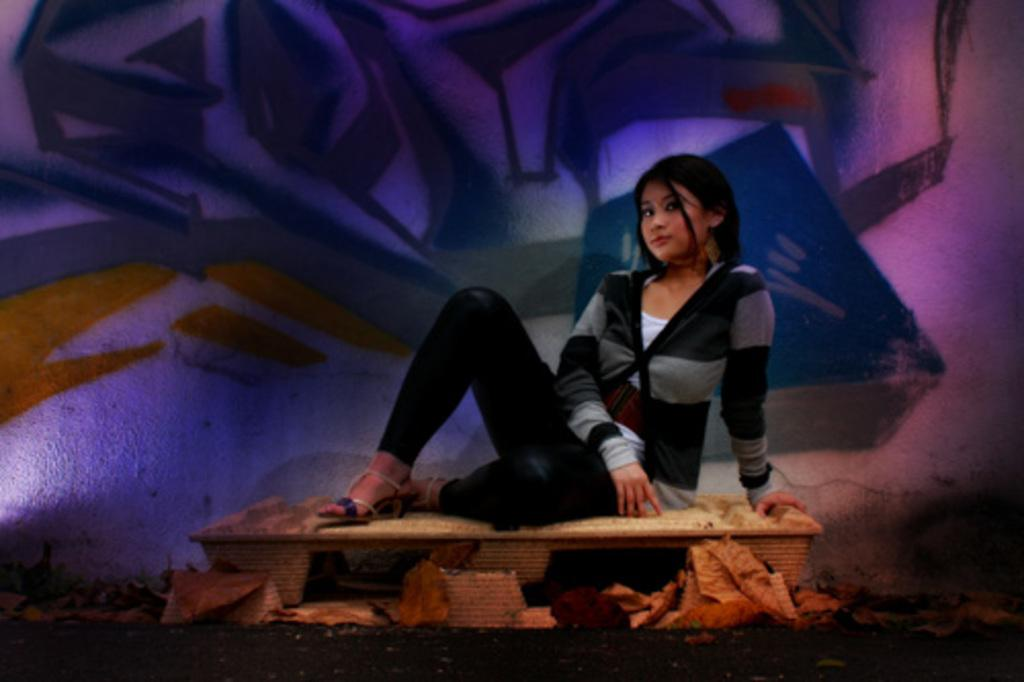What is the woman doing in the image? The woman is sitting on a table in the image. What can be seen in the background of the image? There is a wall in the background of the image. What is on the wall in the image? There is a painting on the wall in the image. What month is depicted in the painting on the wall? There is no indication of a specific month in the painting on the wall; it is not mentioned in the provided facts. 